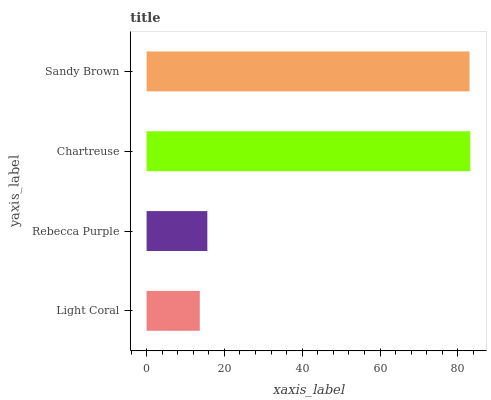Is Light Coral the minimum?
Answer yes or no. Yes. Is Chartreuse the maximum?
Answer yes or no. Yes. Is Rebecca Purple the minimum?
Answer yes or no. No. Is Rebecca Purple the maximum?
Answer yes or no. No. Is Rebecca Purple greater than Light Coral?
Answer yes or no. Yes. Is Light Coral less than Rebecca Purple?
Answer yes or no. Yes. Is Light Coral greater than Rebecca Purple?
Answer yes or no. No. Is Rebecca Purple less than Light Coral?
Answer yes or no. No. Is Sandy Brown the high median?
Answer yes or no. Yes. Is Rebecca Purple the low median?
Answer yes or no. Yes. Is Light Coral the high median?
Answer yes or no. No. Is Sandy Brown the low median?
Answer yes or no. No. 